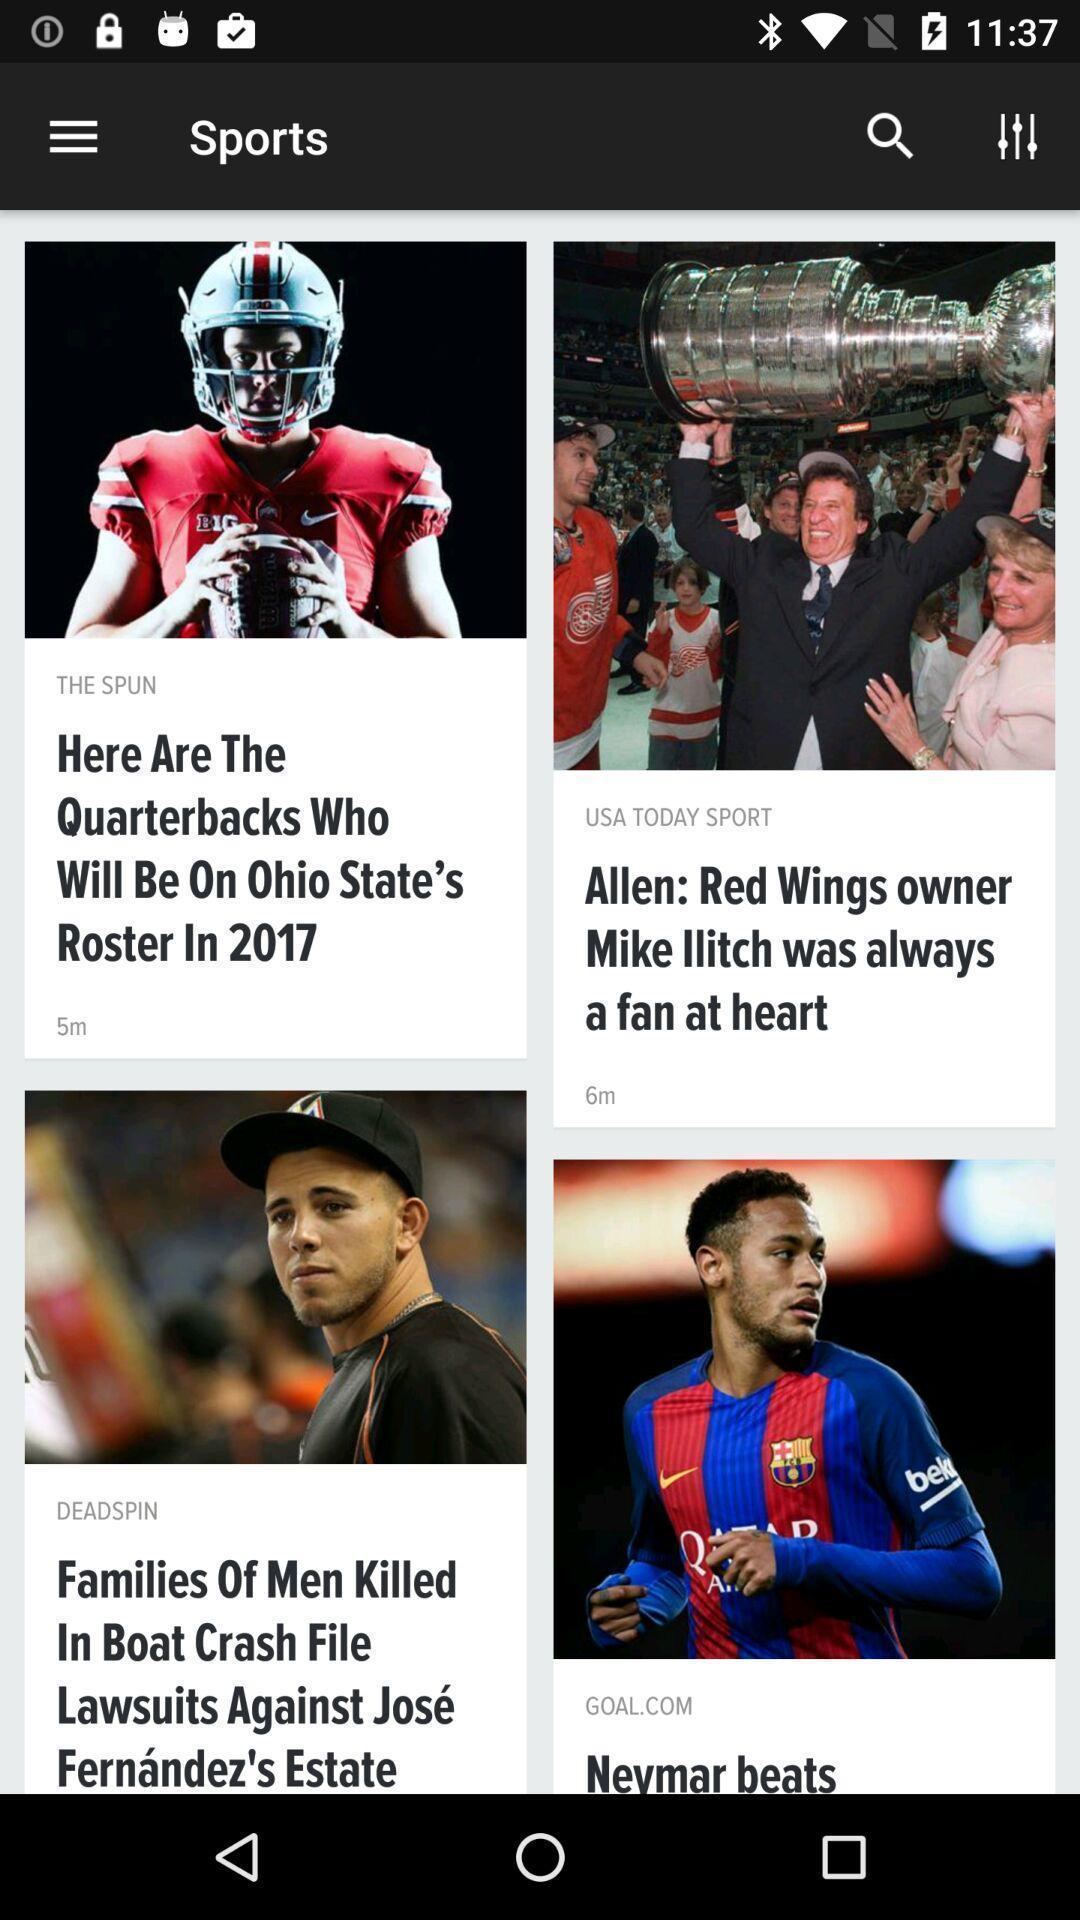Tell me what you see in this picture. Screen shows sports new in a news app. 